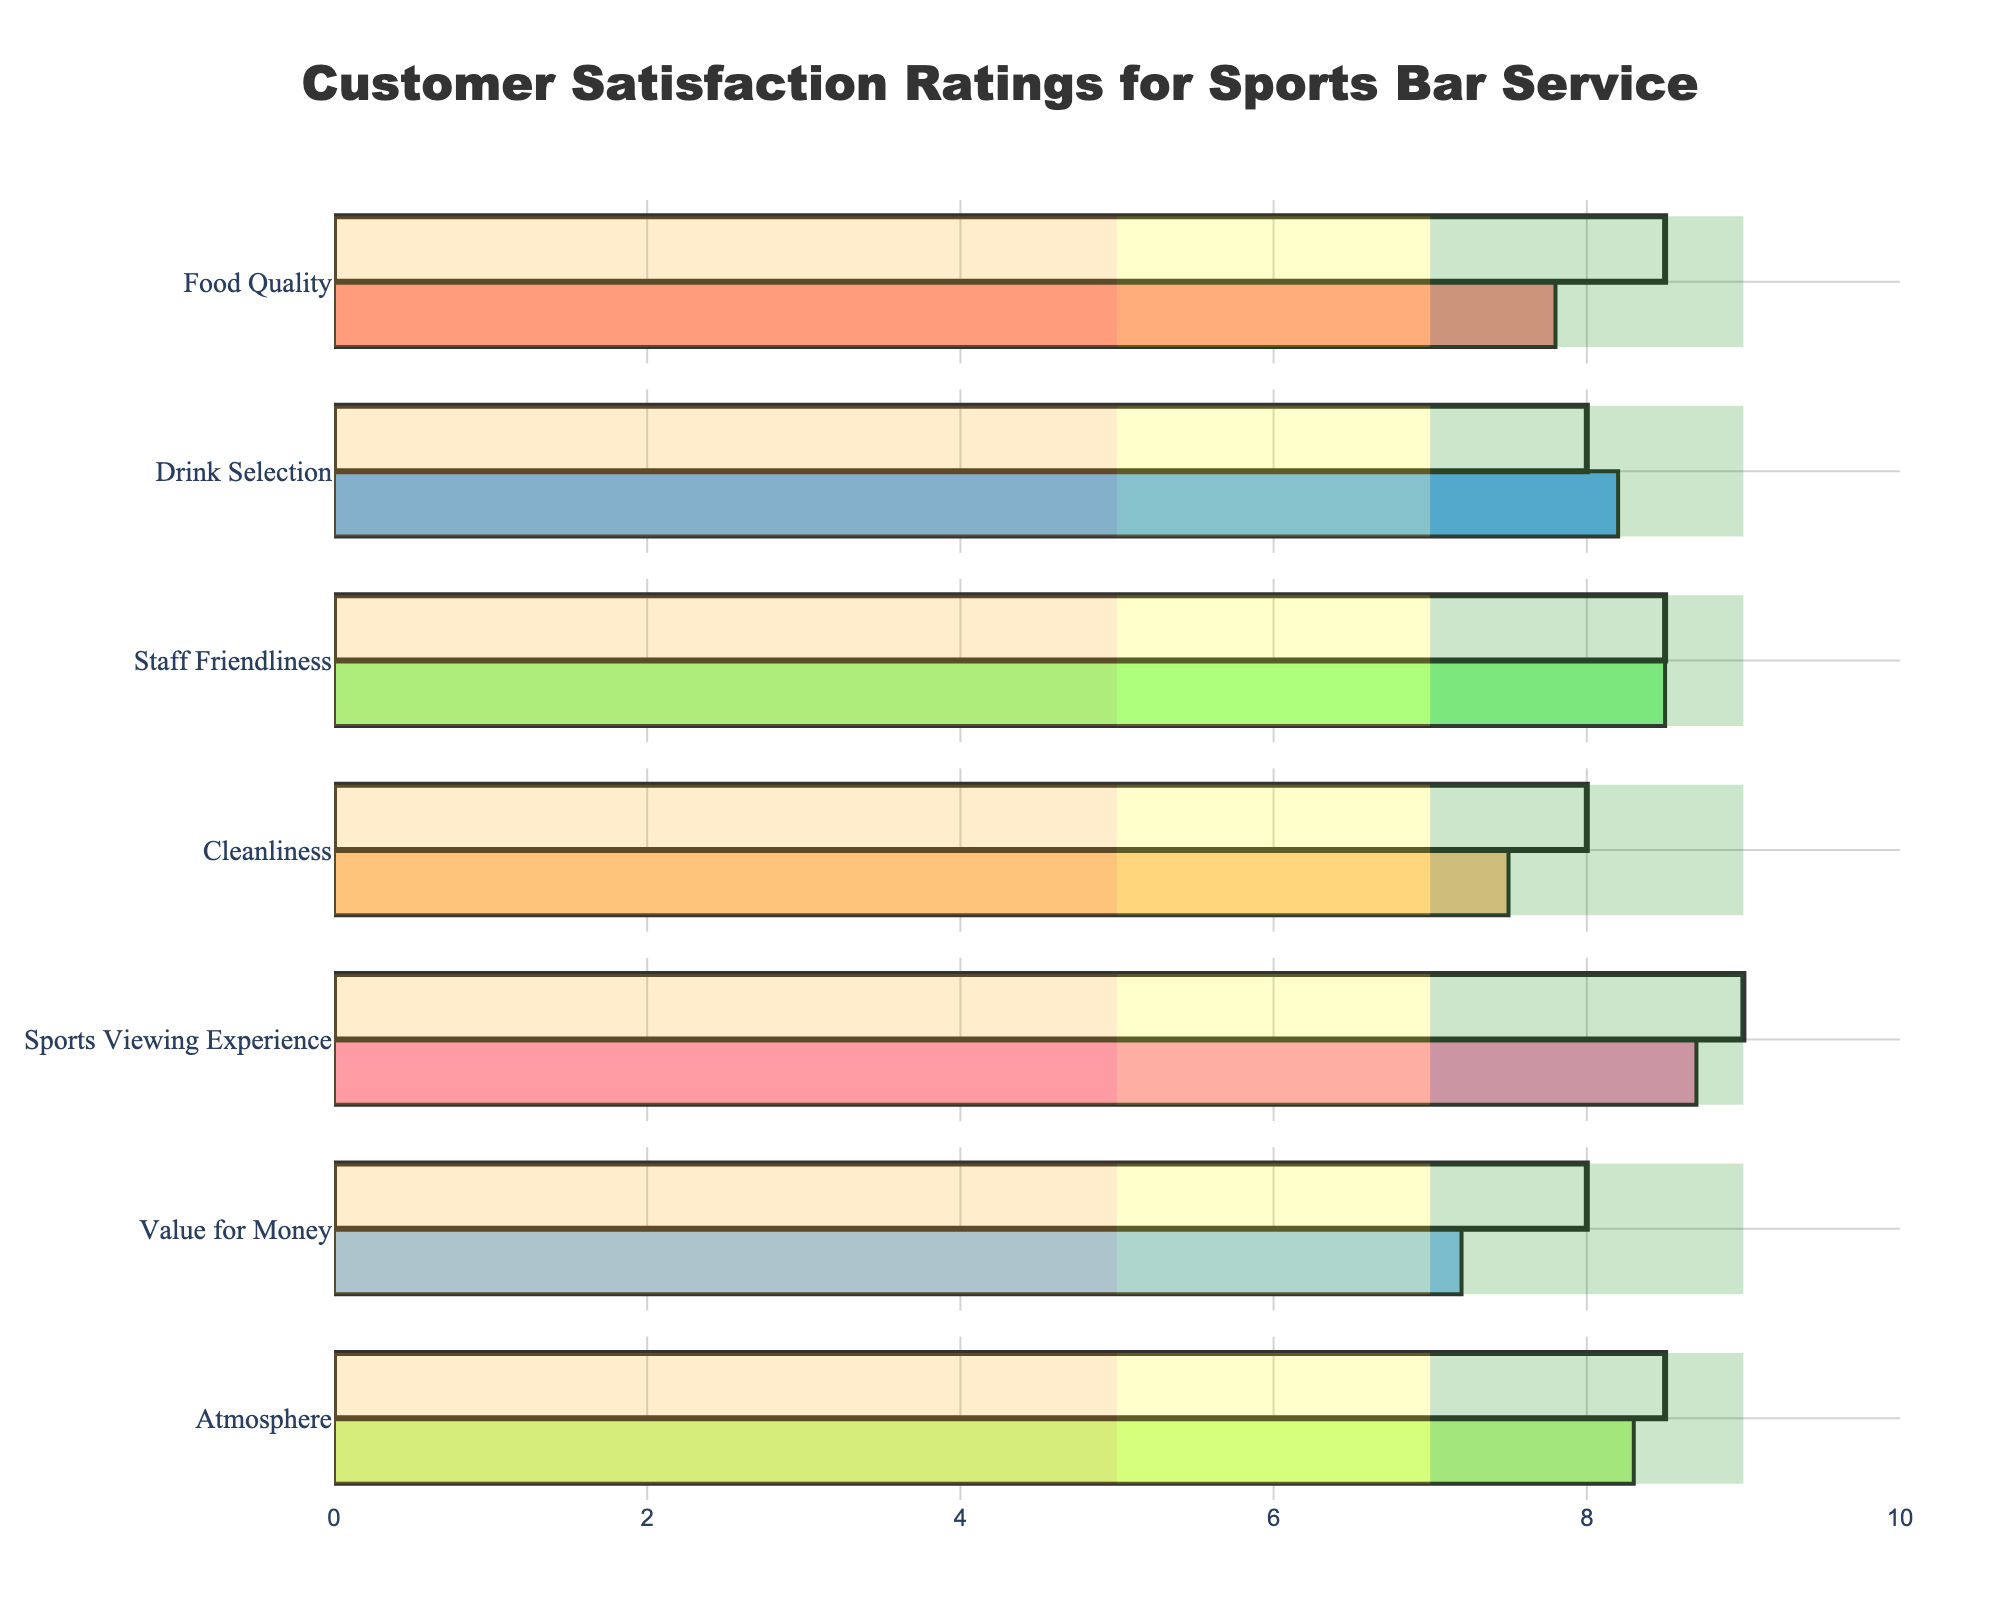What aspect has the highest Actual satisfaction rating? Look at the Actual satisfaction ratings for each aspect. The highest value among them is 8.7 for the Sports Viewing Experience.
Answer: Sports Viewing Experience Which aspects met or exceeded their Target satisfaction ratings? Check both the Actual and Target ratings for each aspect. The ones where the Actual rating is greater than or equal to the Target rating are 'Drink Selection,' 'Staff Friendliness,' and 'Atmosphere.'
Answer: Drink Selection, Staff Friendliness, Atmosphere What's the lowest Actual satisfaction rating, and which aspect does it correspond to? Identify the lowest value among the Actual satisfaction ratings. The lowest value is 7.2, which corresponds to 'Value for Money.'
Answer: Value for Money How does the Actual rating for 'Food Quality' compare to the Target? Compare the Actual and Target satisfaction ratings for 'Food Quality.' The Actual rating is 7.8, and the Target rating is 8.5. Hence, the Actual rating is below the Target.
Answer: Below Target Which aspect has the biggest difference between the Target and Actual ratings? Calculate the differences between the Target and Actual ratings for each aspect and identify the largest difference.
Answer: Value for Money Are all the ratings for 'Atmosphere' in the 'Good' or 'Excellent' range? Check the Actual rating for 'Atmosphere' and compare it with the ranges for 'Good' (7 to 9) and 'Excellent' (above 9). The Actual rating is 8.3, which falls in the 'Good' range.
Answer: Yes What's the combined Actual rating for 'Cleanliness' and 'Sports Viewing Experience'? Find the Actual ratings for both 'Cleanliness' and 'Sports Viewing Experience,' then add them together. The Actual rating for Cleanliness is 7.5, and for Sports Viewing Experience, it is 8.7. Adding these gives 7.5 + 8.7 = 16.2.
Answer: 16.2 Which aspect has an Actual rating closest to its 'Poor' threshold? Compare the Actual ratings of all aspects to their respective 'Poor' threshold (5). The closest value to 5 is 7.2 (Value for Money).
Answer: Value for Money What are the ranges (Poor, Fair, Good, Excellent) for 'Drink Selection'? Look at the predefined ranges for 'Drink Selection': Poor (0 to 5), Fair (5 to 7), Good (7 to 9), and Excellent (9 and above).
Answer: Poor: 0-5, Fair: 5-7, Good: 7-9, Excellent: above 9 